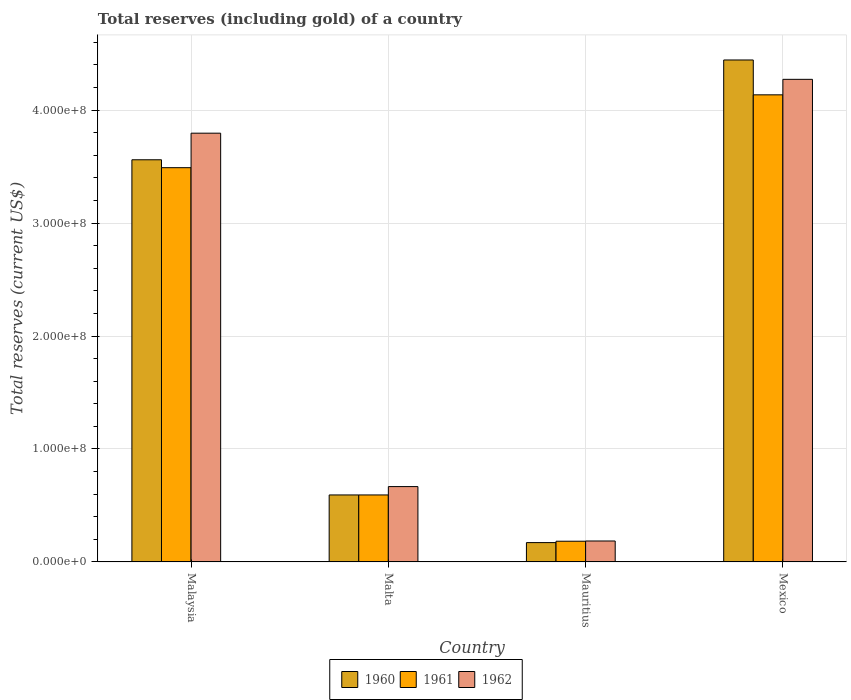How many different coloured bars are there?
Your answer should be compact. 3. Are the number of bars per tick equal to the number of legend labels?
Provide a short and direct response. Yes. Are the number of bars on each tick of the X-axis equal?
Your answer should be very brief. Yes. In how many cases, is the number of bars for a given country not equal to the number of legend labels?
Keep it short and to the point. 0. What is the total reserves (including gold) in 1960 in Mauritius?
Offer a terse response. 1.71e+07. Across all countries, what is the maximum total reserves (including gold) in 1961?
Offer a terse response. 4.13e+08. Across all countries, what is the minimum total reserves (including gold) in 1960?
Ensure brevity in your answer.  1.71e+07. In which country was the total reserves (including gold) in 1960 maximum?
Give a very brief answer. Mexico. In which country was the total reserves (including gold) in 1960 minimum?
Give a very brief answer. Mauritius. What is the total total reserves (including gold) in 1960 in the graph?
Your answer should be compact. 8.77e+08. What is the difference between the total reserves (including gold) in 1960 in Malaysia and that in Malta?
Keep it short and to the point. 2.97e+08. What is the difference between the total reserves (including gold) in 1961 in Malaysia and the total reserves (including gold) in 1962 in Mexico?
Give a very brief answer. -7.82e+07. What is the average total reserves (including gold) in 1961 per country?
Provide a succinct answer. 2.10e+08. What is the difference between the total reserves (including gold) of/in 1962 and total reserves (including gold) of/in 1960 in Malaysia?
Your answer should be very brief. 2.35e+07. What is the ratio of the total reserves (including gold) in 1961 in Malaysia to that in Mexico?
Your answer should be compact. 0.84. What is the difference between the highest and the second highest total reserves (including gold) in 1960?
Give a very brief answer. 2.97e+08. What is the difference between the highest and the lowest total reserves (including gold) in 1962?
Keep it short and to the point. 4.09e+08. In how many countries, is the total reserves (including gold) in 1962 greater than the average total reserves (including gold) in 1962 taken over all countries?
Make the answer very short. 2. Is the sum of the total reserves (including gold) in 1961 in Malaysia and Mexico greater than the maximum total reserves (including gold) in 1960 across all countries?
Offer a terse response. Yes. What does the 3rd bar from the right in Malta represents?
Make the answer very short. 1960. Is it the case that in every country, the sum of the total reserves (including gold) in 1961 and total reserves (including gold) in 1960 is greater than the total reserves (including gold) in 1962?
Provide a short and direct response. Yes. How many bars are there?
Offer a terse response. 12. Are all the bars in the graph horizontal?
Keep it short and to the point. No. How many countries are there in the graph?
Ensure brevity in your answer.  4. Are the values on the major ticks of Y-axis written in scientific E-notation?
Your answer should be very brief. Yes. Does the graph contain grids?
Your answer should be very brief. Yes. Where does the legend appear in the graph?
Your answer should be very brief. Bottom center. What is the title of the graph?
Your answer should be compact. Total reserves (including gold) of a country. Does "2003" appear as one of the legend labels in the graph?
Provide a succinct answer. No. What is the label or title of the X-axis?
Offer a very short reply. Country. What is the label or title of the Y-axis?
Offer a terse response. Total reserves (current US$). What is the Total reserves (current US$) in 1960 in Malaysia?
Provide a short and direct response. 3.56e+08. What is the Total reserves (current US$) in 1961 in Malaysia?
Offer a very short reply. 3.49e+08. What is the Total reserves (current US$) in 1962 in Malaysia?
Keep it short and to the point. 3.80e+08. What is the Total reserves (current US$) of 1960 in Malta?
Keep it short and to the point. 5.93e+07. What is the Total reserves (current US$) of 1961 in Malta?
Ensure brevity in your answer.  5.93e+07. What is the Total reserves (current US$) of 1962 in Malta?
Offer a very short reply. 6.67e+07. What is the Total reserves (current US$) in 1960 in Mauritius?
Your response must be concise. 1.71e+07. What is the Total reserves (current US$) in 1961 in Mauritius?
Give a very brief answer. 1.83e+07. What is the Total reserves (current US$) in 1962 in Mauritius?
Your answer should be compact. 1.86e+07. What is the Total reserves (current US$) in 1960 in Mexico?
Make the answer very short. 4.44e+08. What is the Total reserves (current US$) of 1961 in Mexico?
Make the answer very short. 4.13e+08. What is the Total reserves (current US$) of 1962 in Mexico?
Keep it short and to the point. 4.27e+08. Across all countries, what is the maximum Total reserves (current US$) of 1960?
Ensure brevity in your answer.  4.44e+08. Across all countries, what is the maximum Total reserves (current US$) in 1961?
Ensure brevity in your answer.  4.13e+08. Across all countries, what is the maximum Total reserves (current US$) of 1962?
Provide a succinct answer. 4.27e+08. Across all countries, what is the minimum Total reserves (current US$) of 1960?
Give a very brief answer. 1.71e+07. Across all countries, what is the minimum Total reserves (current US$) in 1961?
Offer a very short reply. 1.83e+07. Across all countries, what is the minimum Total reserves (current US$) in 1962?
Your answer should be compact. 1.86e+07. What is the total Total reserves (current US$) of 1960 in the graph?
Give a very brief answer. 8.77e+08. What is the total Total reserves (current US$) in 1961 in the graph?
Keep it short and to the point. 8.40e+08. What is the total Total reserves (current US$) in 1962 in the graph?
Provide a succinct answer. 8.92e+08. What is the difference between the Total reserves (current US$) in 1960 in Malaysia and that in Malta?
Provide a succinct answer. 2.97e+08. What is the difference between the Total reserves (current US$) in 1961 in Malaysia and that in Malta?
Provide a short and direct response. 2.90e+08. What is the difference between the Total reserves (current US$) in 1962 in Malaysia and that in Malta?
Your response must be concise. 3.13e+08. What is the difference between the Total reserves (current US$) in 1960 in Malaysia and that in Mauritius?
Provide a succinct answer. 3.39e+08. What is the difference between the Total reserves (current US$) of 1961 in Malaysia and that in Mauritius?
Make the answer very short. 3.31e+08. What is the difference between the Total reserves (current US$) of 1962 in Malaysia and that in Mauritius?
Your response must be concise. 3.61e+08. What is the difference between the Total reserves (current US$) of 1960 in Malaysia and that in Mexico?
Offer a very short reply. -8.83e+07. What is the difference between the Total reserves (current US$) of 1961 in Malaysia and that in Mexico?
Offer a terse response. -6.45e+07. What is the difference between the Total reserves (current US$) of 1962 in Malaysia and that in Mexico?
Your response must be concise. -4.77e+07. What is the difference between the Total reserves (current US$) in 1960 in Malta and that in Mauritius?
Make the answer very short. 4.22e+07. What is the difference between the Total reserves (current US$) of 1961 in Malta and that in Mauritius?
Provide a succinct answer. 4.10e+07. What is the difference between the Total reserves (current US$) of 1962 in Malta and that in Mauritius?
Offer a terse response. 4.82e+07. What is the difference between the Total reserves (current US$) of 1960 in Malta and that in Mexico?
Your answer should be compact. -3.85e+08. What is the difference between the Total reserves (current US$) in 1961 in Malta and that in Mexico?
Keep it short and to the point. -3.54e+08. What is the difference between the Total reserves (current US$) in 1962 in Malta and that in Mexico?
Your answer should be compact. -3.60e+08. What is the difference between the Total reserves (current US$) in 1960 in Mauritius and that in Mexico?
Your answer should be compact. -4.27e+08. What is the difference between the Total reserves (current US$) of 1961 in Mauritius and that in Mexico?
Provide a succinct answer. -3.95e+08. What is the difference between the Total reserves (current US$) of 1962 in Mauritius and that in Mexico?
Your answer should be very brief. -4.09e+08. What is the difference between the Total reserves (current US$) of 1960 in Malaysia and the Total reserves (current US$) of 1961 in Malta?
Provide a succinct answer. 2.97e+08. What is the difference between the Total reserves (current US$) of 1960 in Malaysia and the Total reserves (current US$) of 1962 in Malta?
Provide a short and direct response. 2.89e+08. What is the difference between the Total reserves (current US$) in 1961 in Malaysia and the Total reserves (current US$) in 1962 in Malta?
Offer a terse response. 2.82e+08. What is the difference between the Total reserves (current US$) in 1960 in Malaysia and the Total reserves (current US$) in 1961 in Mauritius?
Ensure brevity in your answer.  3.38e+08. What is the difference between the Total reserves (current US$) of 1960 in Malaysia and the Total reserves (current US$) of 1962 in Mauritius?
Keep it short and to the point. 3.37e+08. What is the difference between the Total reserves (current US$) in 1961 in Malaysia and the Total reserves (current US$) in 1962 in Mauritius?
Give a very brief answer. 3.30e+08. What is the difference between the Total reserves (current US$) in 1960 in Malaysia and the Total reserves (current US$) in 1961 in Mexico?
Offer a terse response. -5.75e+07. What is the difference between the Total reserves (current US$) in 1960 in Malaysia and the Total reserves (current US$) in 1962 in Mexico?
Your answer should be compact. -7.12e+07. What is the difference between the Total reserves (current US$) of 1961 in Malaysia and the Total reserves (current US$) of 1962 in Mexico?
Provide a succinct answer. -7.82e+07. What is the difference between the Total reserves (current US$) of 1960 in Malta and the Total reserves (current US$) of 1961 in Mauritius?
Your response must be concise. 4.10e+07. What is the difference between the Total reserves (current US$) in 1960 in Malta and the Total reserves (current US$) in 1962 in Mauritius?
Your answer should be very brief. 4.08e+07. What is the difference between the Total reserves (current US$) in 1961 in Malta and the Total reserves (current US$) in 1962 in Mauritius?
Offer a terse response. 4.08e+07. What is the difference between the Total reserves (current US$) of 1960 in Malta and the Total reserves (current US$) of 1961 in Mexico?
Provide a short and direct response. -3.54e+08. What is the difference between the Total reserves (current US$) of 1960 in Malta and the Total reserves (current US$) of 1962 in Mexico?
Your answer should be very brief. -3.68e+08. What is the difference between the Total reserves (current US$) of 1961 in Malta and the Total reserves (current US$) of 1962 in Mexico?
Your answer should be very brief. -3.68e+08. What is the difference between the Total reserves (current US$) in 1960 in Mauritius and the Total reserves (current US$) in 1961 in Mexico?
Offer a very short reply. -3.96e+08. What is the difference between the Total reserves (current US$) in 1960 in Mauritius and the Total reserves (current US$) in 1962 in Mexico?
Offer a very short reply. -4.10e+08. What is the difference between the Total reserves (current US$) in 1961 in Mauritius and the Total reserves (current US$) in 1962 in Mexico?
Your answer should be very brief. -4.09e+08. What is the average Total reserves (current US$) in 1960 per country?
Your answer should be compact. 2.19e+08. What is the average Total reserves (current US$) of 1961 per country?
Keep it short and to the point. 2.10e+08. What is the average Total reserves (current US$) in 1962 per country?
Provide a short and direct response. 2.23e+08. What is the difference between the Total reserves (current US$) of 1960 and Total reserves (current US$) of 1962 in Malaysia?
Your answer should be very brief. -2.35e+07. What is the difference between the Total reserves (current US$) of 1961 and Total reserves (current US$) of 1962 in Malaysia?
Your answer should be very brief. -3.05e+07. What is the difference between the Total reserves (current US$) in 1960 and Total reserves (current US$) in 1961 in Malta?
Your answer should be compact. 0. What is the difference between the Total reserves (current US$) in 1960 and Total reserves (current US$) in 1962 in Malta?
Offer a terse response. -7.40e+06. What is the difference between the Total reserves (current US$) of 1961 and Total reserves (current US$) of 1962 in Malta?
Ensure brevity in your answer.  -7.40e+06. What is the difference between the Total reserves (current US$) in 1960 and Total reserves (current US$) in 1961 in Mauritius?
Keep it short and to the point. -1.22e+06. What is the difference between the Total reserves (current US$) of 1960 and Total reserves (current US$) of 1962 in Mauritius?
Offer a terse response. -1.43e+06. What is the difference between the Total reserves (current US$) of 1960 and Total reserves (current US$) of 1961 in Mexico?
Provide a succinct answer. 3.09e+07. What is the difference between the Total reserves (current US$) of 1960 and Total reserves (current US$) of 1962 in Mexico?
Your response must be concise. 1.71e+07. What is the difference between the Total reserves (current US$) in 1961 and Total reserves (current US$) in 1962 in Mexico?
Provide a short and direct response. -1.37e+07. What is the ratio of the Total reserves (current US$) of 1960 in Malaysia to that in Malta?
Provide a short and direct response. 6. What is the ratio of the Total reserves (current US$) in 1961 in Malaysia to that in Malta?
Offer a terse response. 5.89. What is the ratio of the Total reserves (current US$) of 1962 in Malaysia to that in Malta?
Your answer should be compact. 5.69. What is the ratio of the Total reserves (current US$) of 1960 in Malaysia to that in Mauritius?
Provide a short and direct response. 20.79. What is the ratio of the Total reserves (current US$) of 1961 in Malaysia to that in Mauritius?
Make the answer very short. 19.03. What is the ratio of the Total reserves (current US$) of 1962 in Malaysia to that in Mauritius?
Offer a terse response. 20.46. What is the ratio of the Total reserves (current US$) of 1960 in Malaysia to that in Mexico?
Offer a very short reply. 0.8. What is the ratio of the Total reserves (current US$) in 1961 in Malaysia to that in Mexico?
Keep it short and to the point. 0.84. What is the ratio of the Total reserves (current US$) of 1962 in Malaysia to that in Mexico?
Your answer should be very brief. 0.89. What is the ratio of the Total reserves (current US$) of 1960 in Malta to that in Mauritius?
Ensure brevity in your answer.  3.46. What is the ratio of the Total reserves (current US$) in 1961 in Malta to that in Mauritius?
Your response must be concise. 3.23. What is the ratio of the Total reserves (current US$) of 1962 in Malta to that in Mauritius?
Provide a short and direct response. 3.6. What is the ratio of the Total reserves (current US$) in 1960 in Malta to that in Mexico?
Keep it short and to the point. 0.13. What is the ratio of the Total reserves (current US$) in 1961 in Malta to that in Mexico?
Keep it short and to the point. 0.14. What is the ratio of the Total reserves (current US$) in 1962 in Malta to that in Mexico?
Offer a terse response. 0.16. What is the ratio of the Total reserves (current US$) in 1960 in Mauritius to that in Mexico?
Ensure brevity in your answer.  0.04. What is the ratio of the Total reserves (current US$) in 1961 in Mauritius to that in Mexico?
Provide a short and direct response. 0.04. What is the ratio of the Total reserves (current US$) in 1962 in Mauritius to that in Mexico?
Offer a very short reply. 0.04. What is the difference between the highest and the second highest Total reserves (current US$) of 1960?
Provide a short and direct response. 8.83e+07. What is the difference between the highest and the second highest Total reserves (current US$) in 1961?
Offer a terse response. 6.45e+07. What is the difference between the highest and the second highest Total reserves (current US$) in 1962?
Ensure brevity in your answer.  4.77e+07. What is the difference between the highest and the lowest Total reserves (current US$) of 1960?
Offer a terse response. 4.27e+08. What is the difference between the highest and the lowest Total reserves (current US$) of 1961?
Ensure brevity in your answer.  3.95e+08. What is the difference between the highest and the lowest Total reserves (current US$) in 1962?
Make the answer very short. 4.09e+08. 